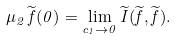<formula> <loc_0><loc_0><loc_500><loc_500>\mu _ { 2 } \, \widetilde { f } ( 0 ) = \lim _ { c _ { 1 } \to 0 } \widetilde { I } ( \widetilde { f } , \widetilde { f } ) .</formula> 